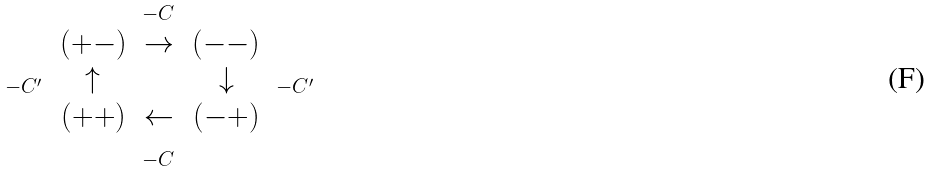Convert formula to latex. <formula><loc_0><loc_0><loc_500><loc_500>\begin{matrix} & & _ { - C } & & \\ & ( + - ) & \rightarrow & ( - - ) & \\ _ { - C ^ { \prime } } & \uparrow & & \downarrow & _ { - C ^ { \prime } } \\ & ( + + ) & \leftarrow & ( - + ) & \\ & & _ { - C } & & \end{matrix}</formula> 